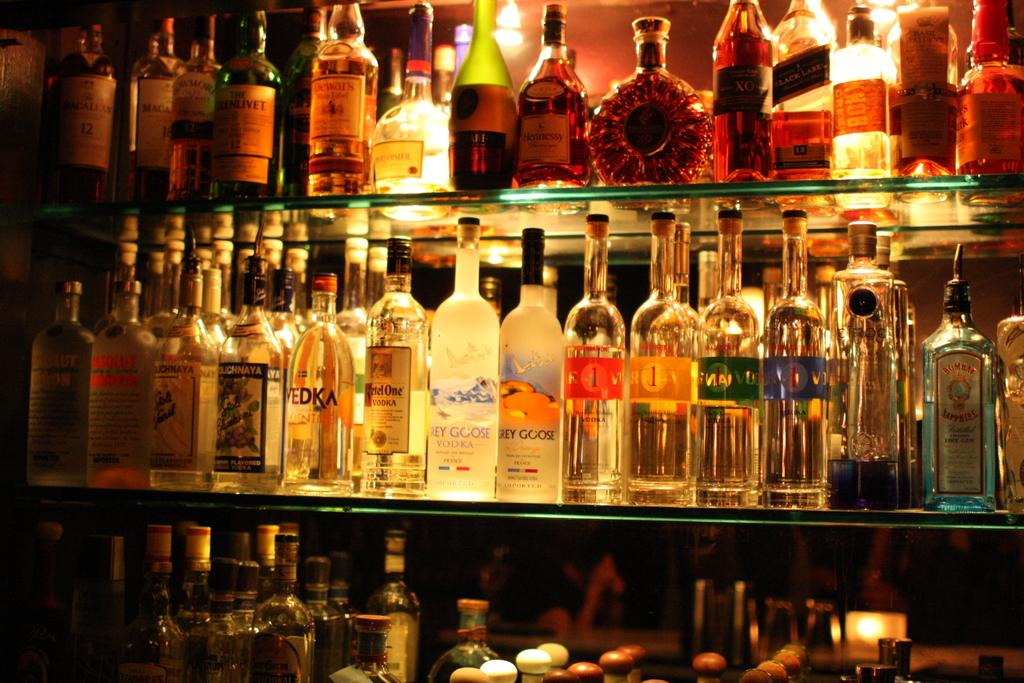<image>
Share a concise interpretation of the image provided. Grey Goose vodka is labeled on the two bottles front and center. 